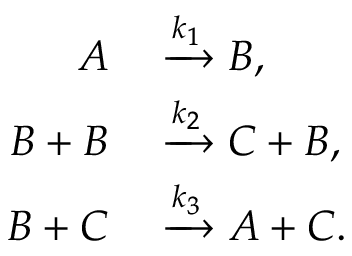Convert formula to latex. <formula><loc_0><loc_0><loc_500><loc_500>\begin{array} { r l } { A } & \xrightarrow { k _ { 1 } } B , } \\ { B + B } & \xrightarrow { k _ { 2 } } C + B , } \\ { B + C } & \xrightarrow { k _ { 3 } } A + C . } \end{array}</formula> 